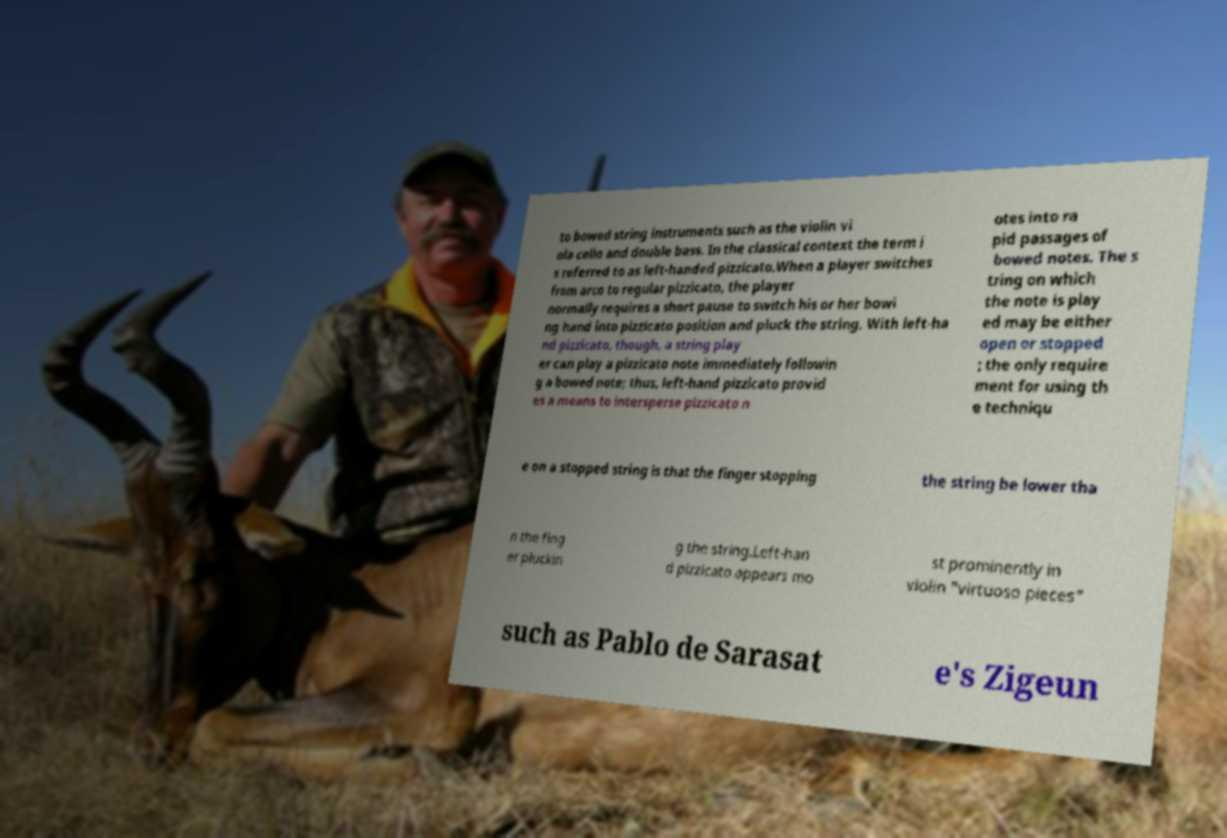Could you assist in decoding the text presented in this image and type it out clearly? to bowed string instruments such as the violin vi ola cello and double bass. In the classical context the term i s referred to as left-handed pizzicato.When a player switches from arco to regular pizzicato, the player normally requires a short pause to switch his or her bowi ng hand into pizzicato position and pluck the string. With left-ha nd pizzicato, though, a string play er can play a pizzicato note immediately followin g a bowed note; thus, left-hand pizzicato provid es a means to intersperse pizzicato n otes into ra pid passages of bowed notes. The s tring on which the note is play ed may be either open or stopped ; the only require ment for using th e techniqu e on a stopped string is that the finger stopping the string be lower tha n the fing er pluckin g the string.Left-han d pizzicato appears mo st prominently in violin "virtuoso pieces" such as Pablo de Sarasat e's Zigeun 